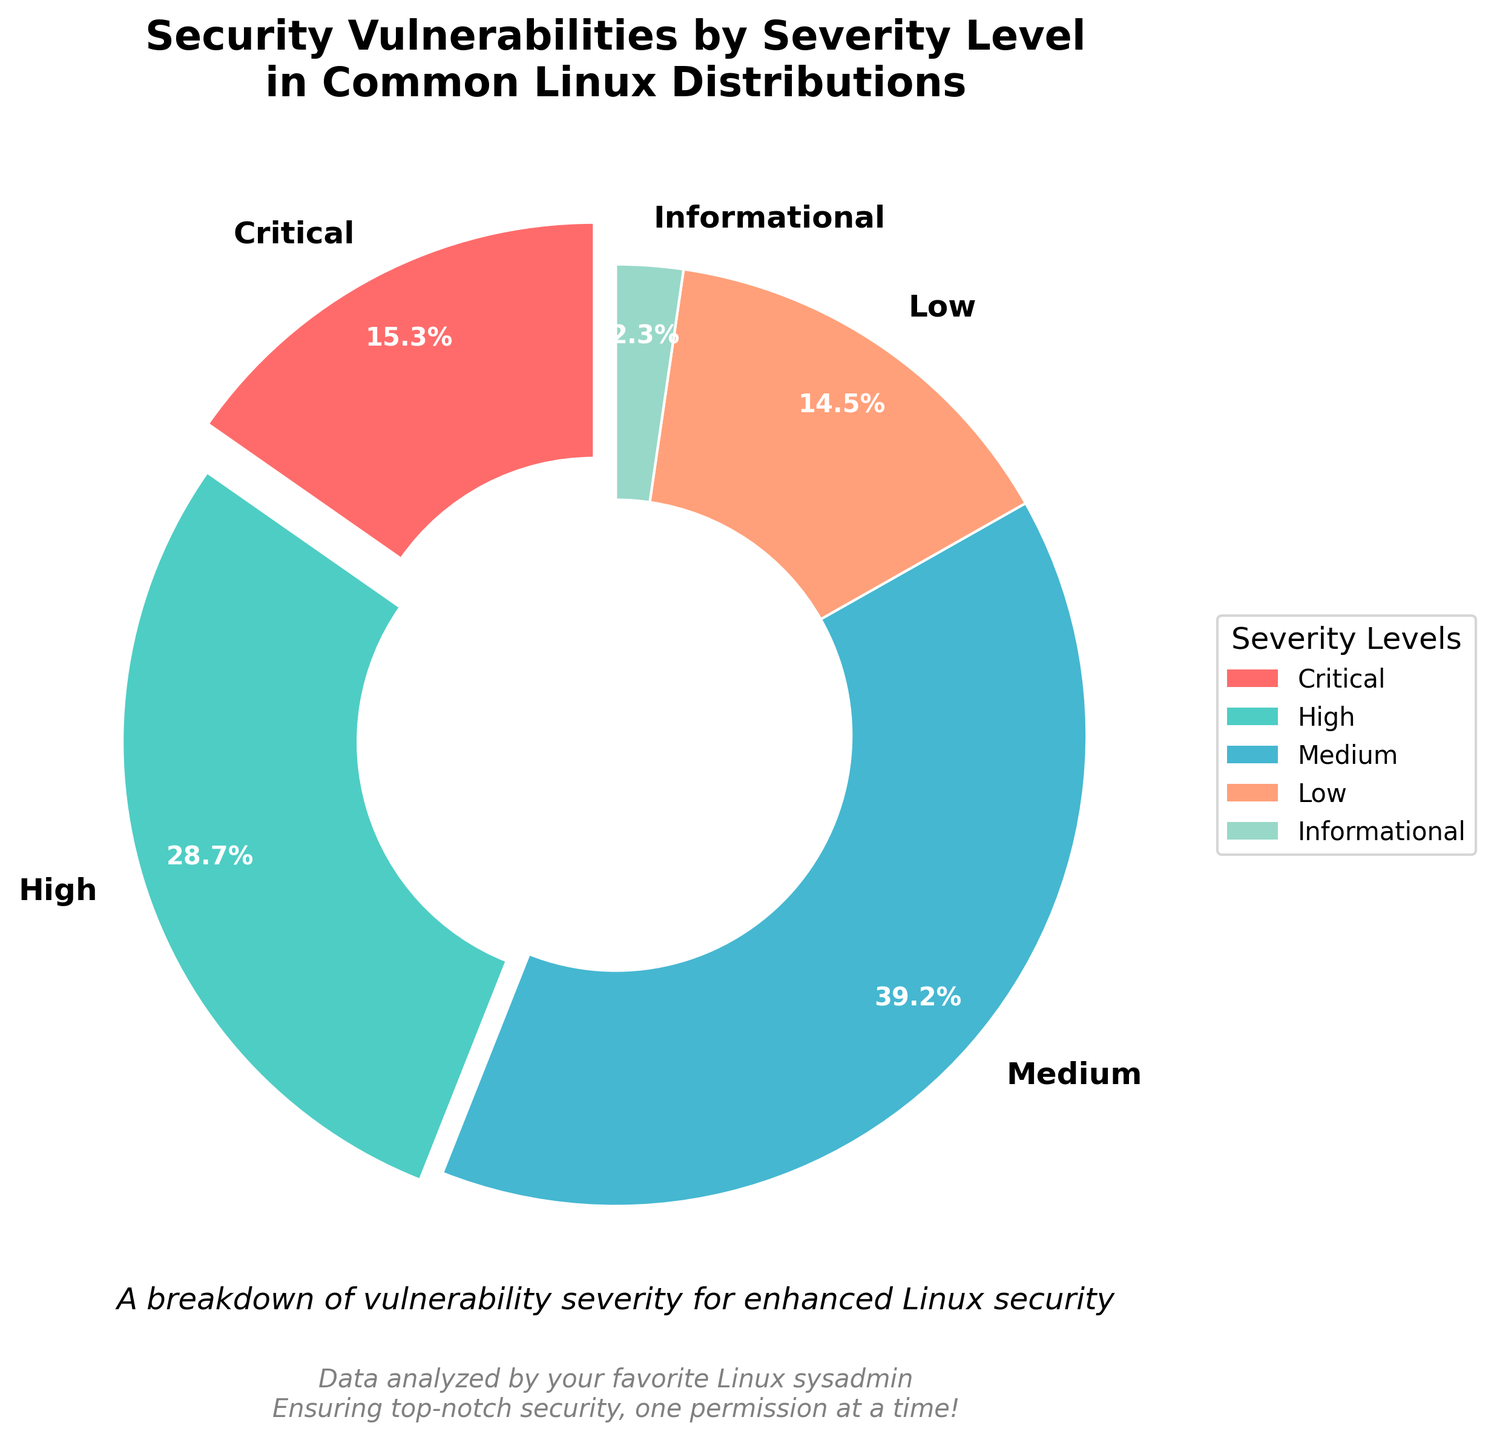Which severity level has the highest percentage of security vulnerabilities? To find the severity level with the highest percentage, observe the segment of the pie chart with the largest size. The 'Medium' severity level occupies the largest portion.
Answer: Medium What's the difference in the percentage of security vulnerabilities between 'High' and 'Critical' severity levels? The percentage for 'High' severity is 28.7% and for 'Critical' severity is 15.3%. Subtract the smaller percentage from the larger one: 28.7% - 15.3% = 13.4%
Answer: 13.4% If you combine 'Low' and 'Informational' severity level vulnerabilities, what will be their total percentage? The percentage of 'Low' severity vulnerabilities is 14.5% and 'Informational' severity is 2.3%. Add the two values: 14.5% + 2.3% = 16.8%
Answer: 16.8% Which severity level is represented by the red segment in the pie chart? Look at the legend to identify the color corresponding to each severity level. The red segment represents the 'Critical' severity level.
Answer: Critical How much more common are 'Medium' severity vulnerabilities compared to 'Low' severity vulnerabilities? The percentage of 'Medium' severity vulnerabilities is 39.2%, and 'Low' severity is 14.5%. To find how much more common 'Medium' is, subtract 'Low' from 'Medium': 39.2% - 14.5% = 24.7%
Answer: 24.7% What is the combined percentage of 'Critical', 'High', and 'Medium' severity vulnerabilities? Add the percentages for 'Critical' (15.3%), 'High' (28.7%), and 'Medium' (39.2%): 15.3% + 28.7% + 39.2% = 83.2%
Answer: 83.2% Which severity levels have a percentage below 15%? Identify the severity levels with percentages less than 15% by looking at the data: 'Critical' (15.3%), 'Low' (14.5%), and 'Informational' (2.3%). Only 'Low' and 'Informational' are below 15%.
Answer: Low, Informational What is the relative size difference between 'Critical' and 'Informational' severities in terms of percentage? The percentage for 'Critical' severity is 15.3% and for 'Informational' is 2.3%. To find the relative size difference, subtract the smaller from the larger: 15.3% - 2.3% = 13.0%
Answer: 13.0% From the pie chart, which segment is least prominent and what is its percentage? The least prominent (smallest) segment in the pie chart represents the 'Informational' severity with a percentage of 2.3%.
Answer: Informational, 2.3% Which severity levels have more than 20% of vulnerabilities? By looking at the data, 'High' has 28.7% and 'Medium' has 39.2%. Both percentages are greater than 20%.
Answer: High, Medium 